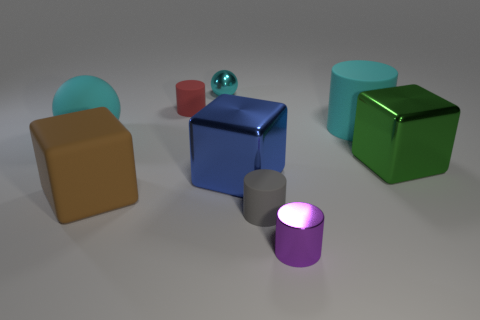Add 1 small metal blocks. How many objects exist? 10 Subtract all rubber cubes. How many cubes are left? 2 Subtract all green blocks. How many blocks are left? 2 Subtract 2 blocks. How many blocks are left? 1 Subtract all gray blocks. Subtract all red cylinders. How many blocks are left? 3 Subtract all cyan cylinders. How many brown cubes are left? 1 Subtract all tiny red rubber things. Subtract all large blocks. How many objects are left? 5 Add 7 large green metallic objects. How many large green metallic objects are left? 8 Add 2 red shiny objects. How many red shiny objects exist? 2 Subtract 0 yellow spheres. How many objects are left? 9 